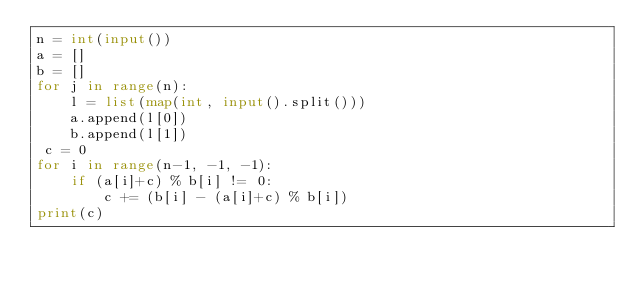Convert code to text. <code><loc_0><loc_0><loc_500><loc_500><_Python_>n = int(input())
a = []
b = []
for j in range(n):
    l = list(map(int, input().split()))
    a.append(l[0])
    b.append(l[1])
 c = 0
for i in range(n-1, -1, -1):
    if (a[i]+c) % b[i] != 0:
        c += (b[i] - (a[i]+c) % b[i])
print(c)</code> 